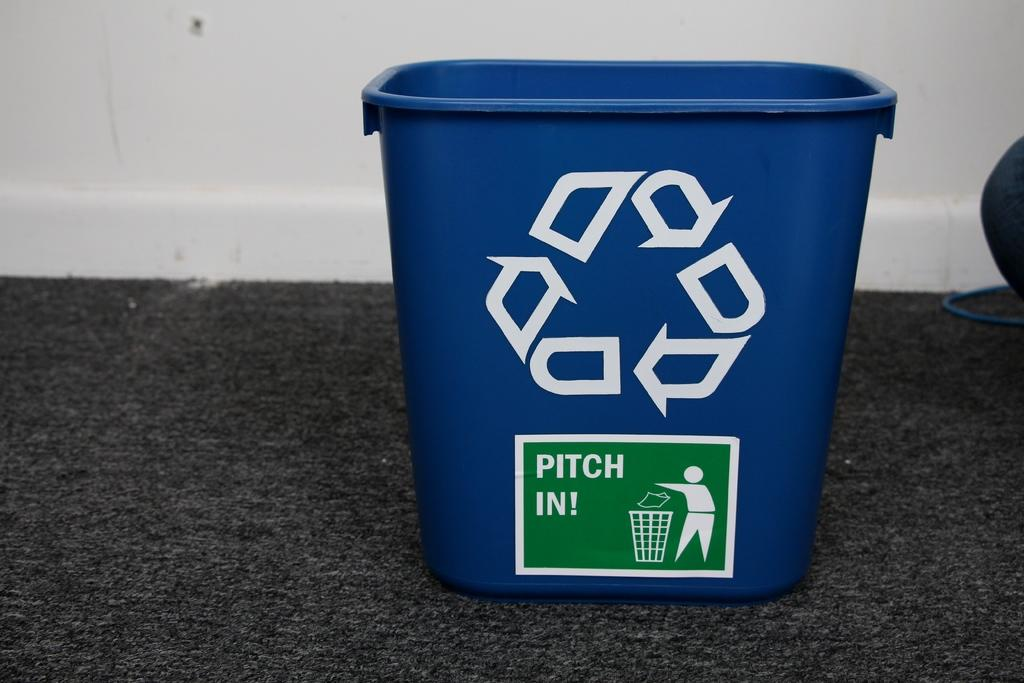<image>
Give a short and clear explanation of the subsequent image. Blue recycle bin that has a green tag which says PITCH IN. 